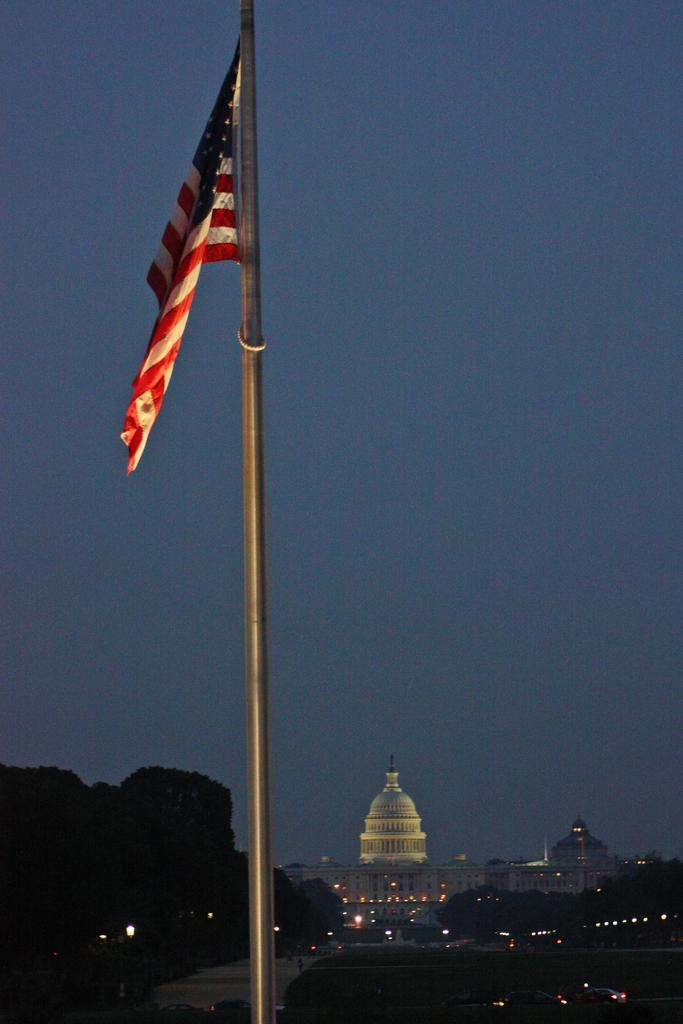What is located in the foreground of the image? There is a pole in the foreground of the image. What is attached to the pole? There is a flag on the pole. What can be seen in the background of the image? There is a building, trees, lights, and the sky visible in the background of the image. Can you tell me how many cats are sitting on the land in the image? There are no cats or land present in the image. What type of bit is being used to cut the flag in the image? There is no bit or cutting activity depicted in the image; the flag is simply attached to the pole. 